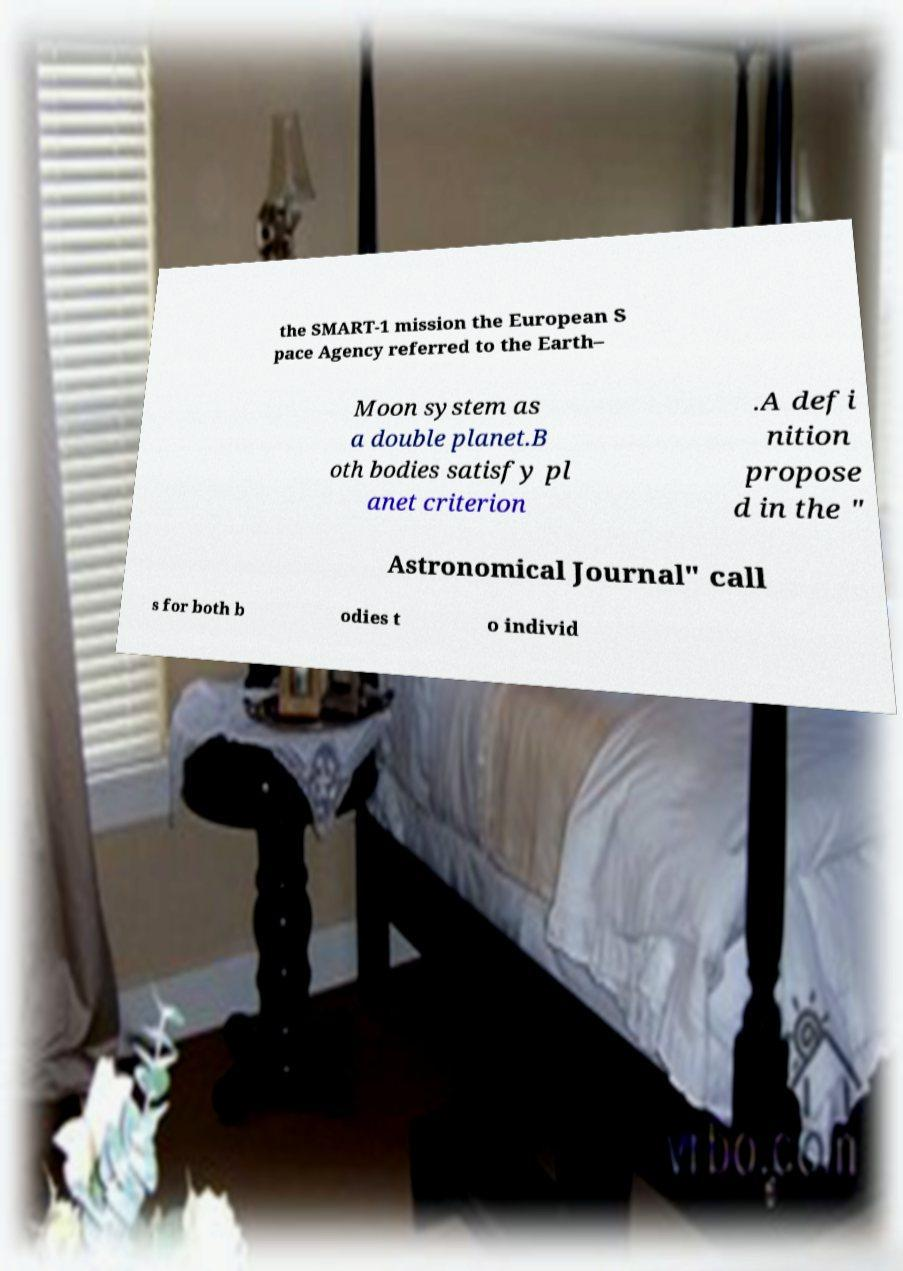Can you read and provide the text displayed in the image?This photo seems to have some interesting text. Can you extract and type it out for me? the SMART-1 mission the European S pace Agency referred to the Earth– Moon system as a double planet.B oth bodies satisfy pl anet criterion .A defi nition propose d in the " Astronomical Journal" call s for both b odies t o individ 